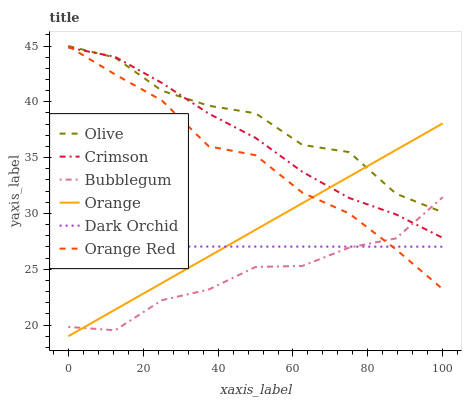Does Bubblegum have the minimum area under the curve?
Answer yes or no. Yes. Does Olive have the maximum area under the curve?
Answer yes or no. Yes. Does Crimson have the minimum area under the curve?
Answer yes or no. No. Does Crimson have the maximum area under the curve?
Answer yes or no. No. Is Orange the smoothest?
Answer yes or no. Yes. Is Olive the roughest?
Answer yes or no. Yes. Is Crimson the smoothest?
Answer yes or no. No. Is Crimson the roughest?
Answer yes or no. No. Does Crimson have the lowest value?
Answer yes or no. No. Does Olive have the highest value?
Answer yes or no. Yes. Does Crimson have the highest value?
Answer yes or no. No. Is Dark Orchid less than Crimson?
Answer yes or no. Yes. Is Crimson greater than Dark Orchid?
Answer yes or no. Yes. Does Orange Red intersect Dark Orchid?
Answer yes or no. Yes. Is Orange Red less than Dark Orchid?
Answer yes or no. No. Is Orange Red greater than Dark Orchid?
Answer yes or no. No. Does Dark Orchid intersect Crimson?
Answer yes or no. No. 